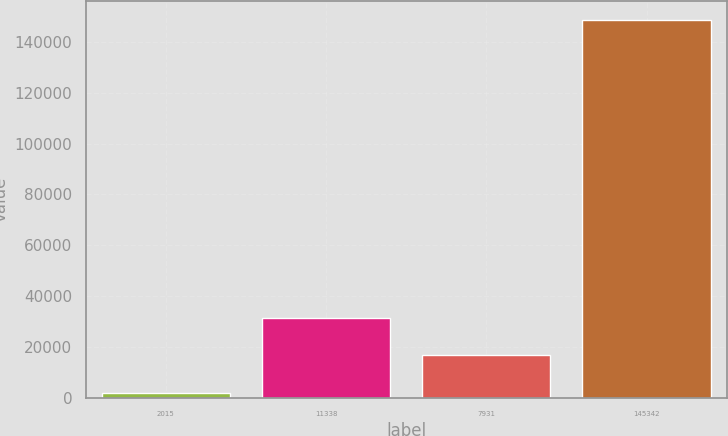Convert chart to OTSL. <chart><loc_0><loc_0><loc_500><loc_500><bar_chart><fcel>2015<fcel>11338<fcel>7931<fcel>145342<nl><fcel>2014<fcel>31373.2<fcel>16693.6<fcel>148810<nl></chart> 